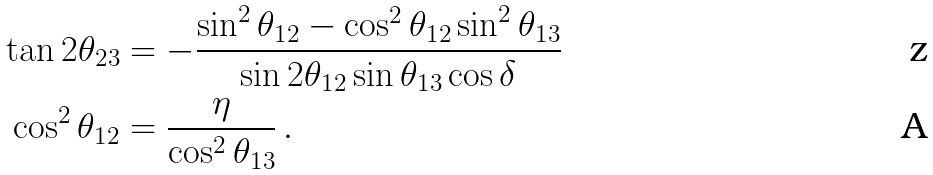Convert formula to latex. <formula><loc_0><loc_0><loc_500><loc_500>\tan 2 \theta _ { 2 3 } & = - \frac { \sin ^ { 2 } \theta _ { 1 2 } - \cos ^ { 2 } \theta _ { 1 2 } \sin ^ { 2 } \theta _ { 1 3 } } { \sin 2 \theta _ { 1 2 } \sin \theta _ { 1 3 } \cos \delta } \\ \cos ^ { 2 } \theta _ { 1 2 } & = \frac { \eta } { \cos ^ { 2 } \theta _ { 1 3 } } \, .</formula> 